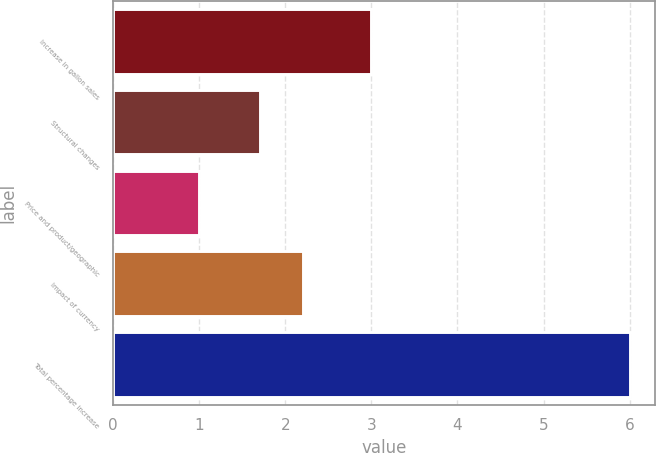Convert chart. <chart><loc_0><loc_0><loc_500><loc_500><bar_chart><fcel>Increase in gallon sales<fcel>Structural changes<fcel>Price and product/geographic<fcel>Impact of currency<fcel>Total percentage increase<nl><fcel>3<fcel>1.71<fcel>1<fcel>2.21<fcel>6<nl></chart> 